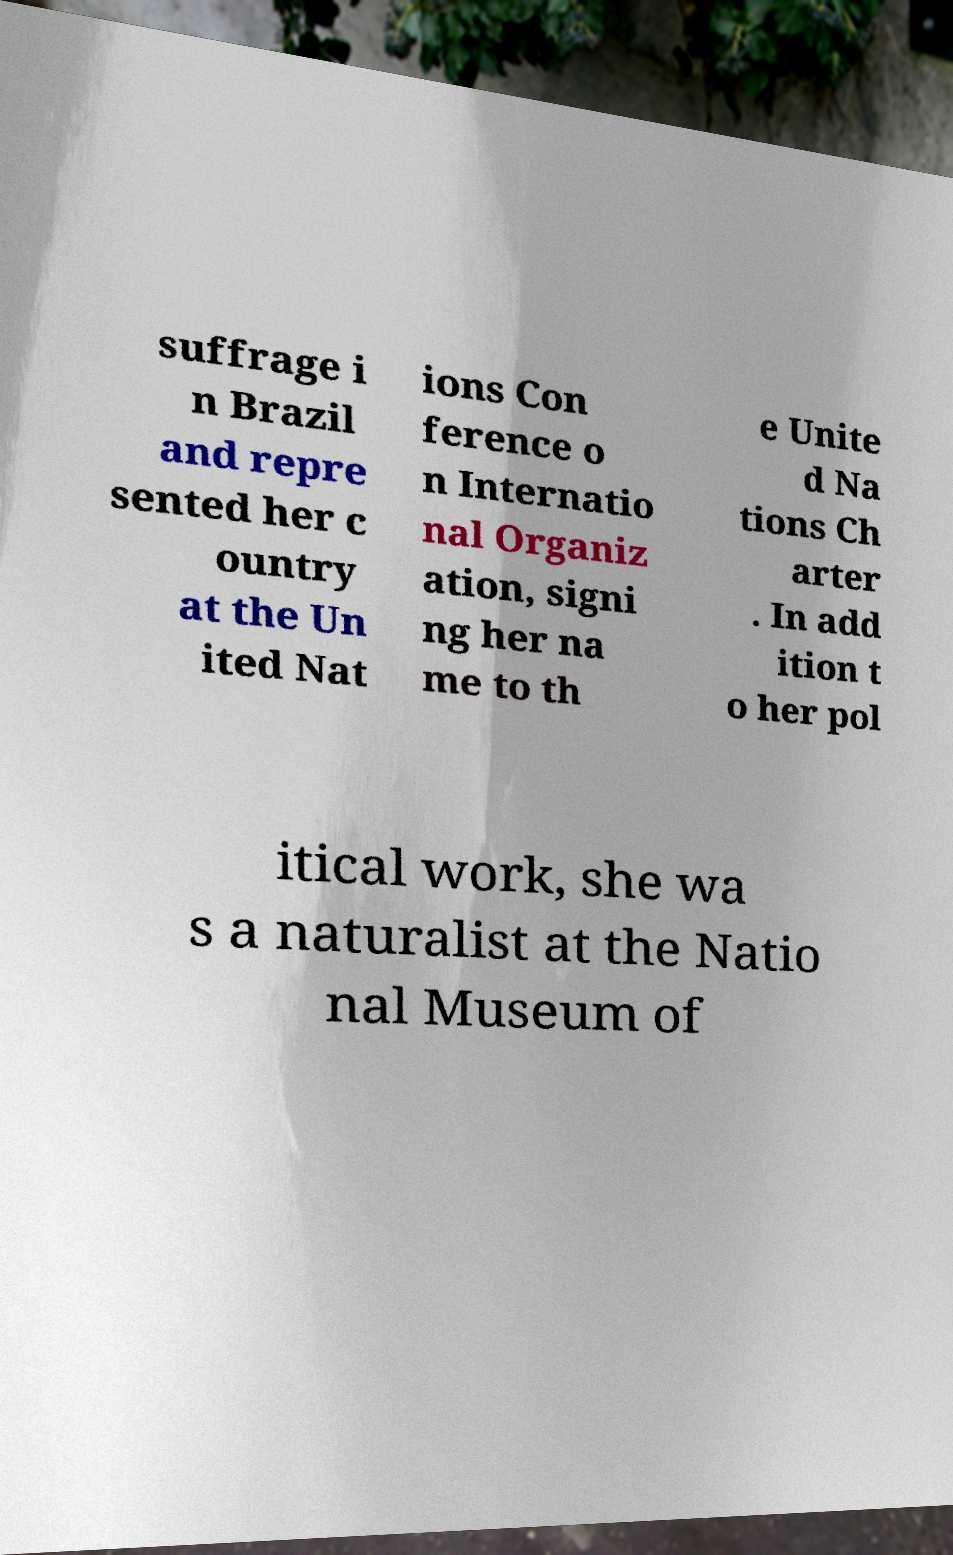There's text embedded in this image that I need extracted. Can you transcribe it verbatim? suffrage i n Brazil and repre sented her c ountry at the Un ited Nat ions Con ference o n Internatio nal Organiz ation, signi ng her na me to th e Unite d Na tions Ch arter . In add ition t o her pol itical work, she wa s a naturalist at the Natio nal Museum of 